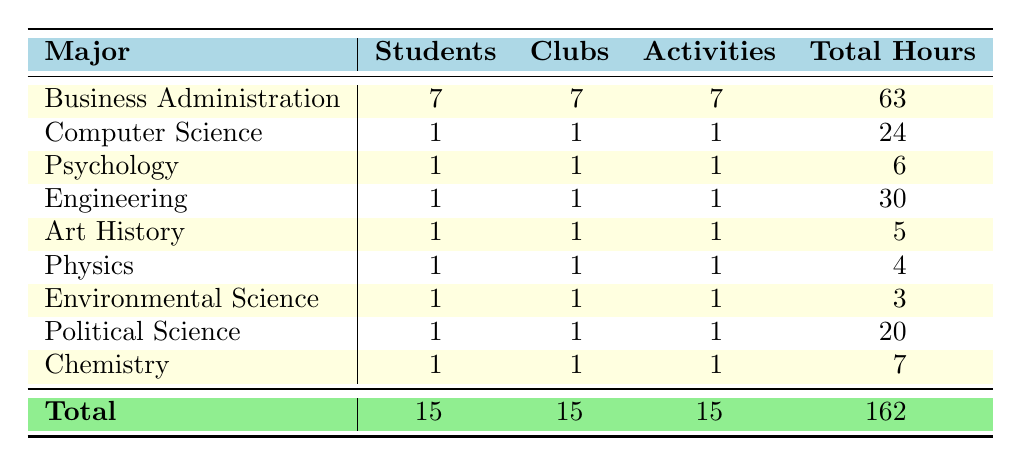What is the total number of students majoring in Business Administration? The table lists the number of students per major, and for Business Administration, the value is provided as 7 under the "Students" column.
Answer: 7 Which major has the highest total hours spent on activities? By comparing the "Total Hours" for each major, Business Administration has the highest total of 63 hours.
Answer: Business Administration How many different clubs are represented by students in Computer Science? The table shows that there is only one entry for Computer Science, which is the Coding Club. Therefore, there is just one club represented.
Answer: 1 What is the average number of hours spent by students in Psychology? There is 1 student in Psychology with a total of 6 hours. Thus, the average is the same as the total since there is only one student: 6 / 1 = 6.
Answer: 6 True or false: There are more clubs than majors in the table. The table shows 15 clubs listed across the majors, while there are 9 different majors. Since 15 is greater than 9, this statement is true.
Answer: True How many more total hours do Business Administration students spend compared to students in Art History? Business Administration students total 63 hours, and Art History students total 5 hours. The difference is 63 - 5 = 58 hours.
Answer: 58 What percentage of the total hours are spent by students in Engineering? The total hours across all majors is 162, and Engineering has 30 hours. The percentage is (30/162) * 100 ≈ 18.52%.
Answer: 18.52% List the majors that have one representative club and their total hours combined. The majors with only one club are Computer Science, Psychology, Engineering, Art History, Physics, Environmental Science, Political Science, and Chemistry. The total hours for these majors sum up to 24 + 6 + 30 + 5 + 4 + 3 + 20 + 7 = 99.
Answer: 99 Which major has the least activity participation and what is the total hours? By comparing total hours, Physics has the least participation with 4 total hours spent on activities.
Answer: Physics, 4 